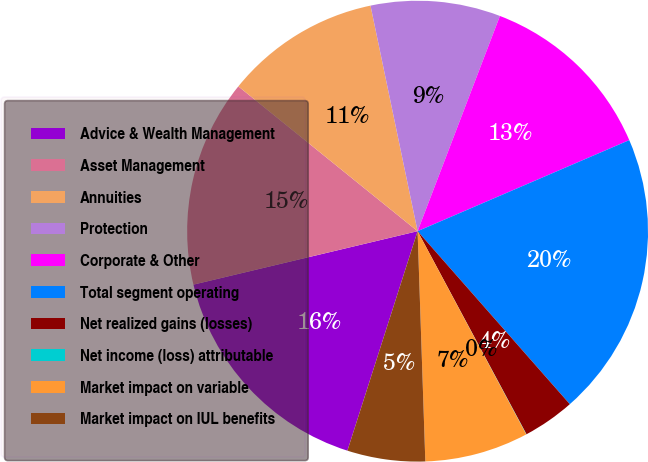Convert chart to OTSL. <chart><loc_0><loc_0><loc_500><loc_500><pie_chart><fcel>Advice & Wealth Management<fcel>Asset Management<fcel>Annuities<fcel>Protection<fcel>Corporate & Other<fcel>Total segment operating<fcel>Net realized gains (losses)<fcel>Net income (loss) attributable<fcel>Market impact on variable<fcel>Market impact on IUL benefits<nl><fcel>16.35%<fcel>14.54%<fcel>10.91%<fcel>9.09%<fcel>12.72%<fcel>19.98%<fcel>3.65%<fcel>0.02%<fcel>7.28%<fcel>5.46%<nl></chart> 